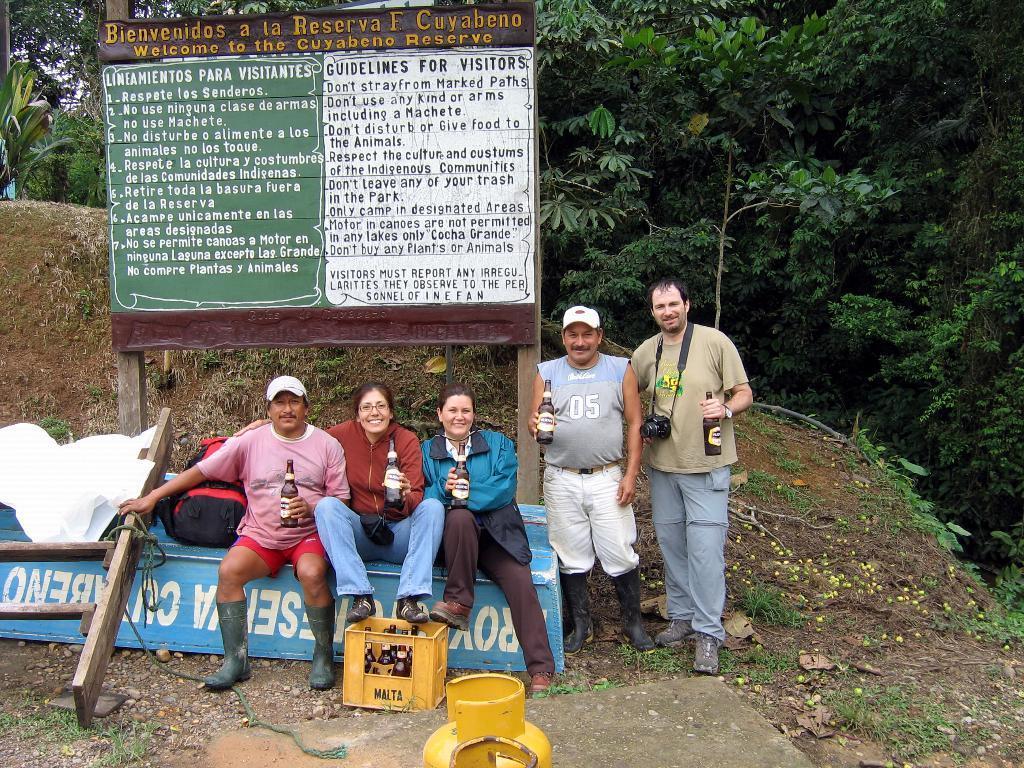Please provide a concise description of this image. In this image we can see persons standing and sitting on the ground and holding beverage bottles in their hands. In the background we can see trees, sky, information board and a case. 